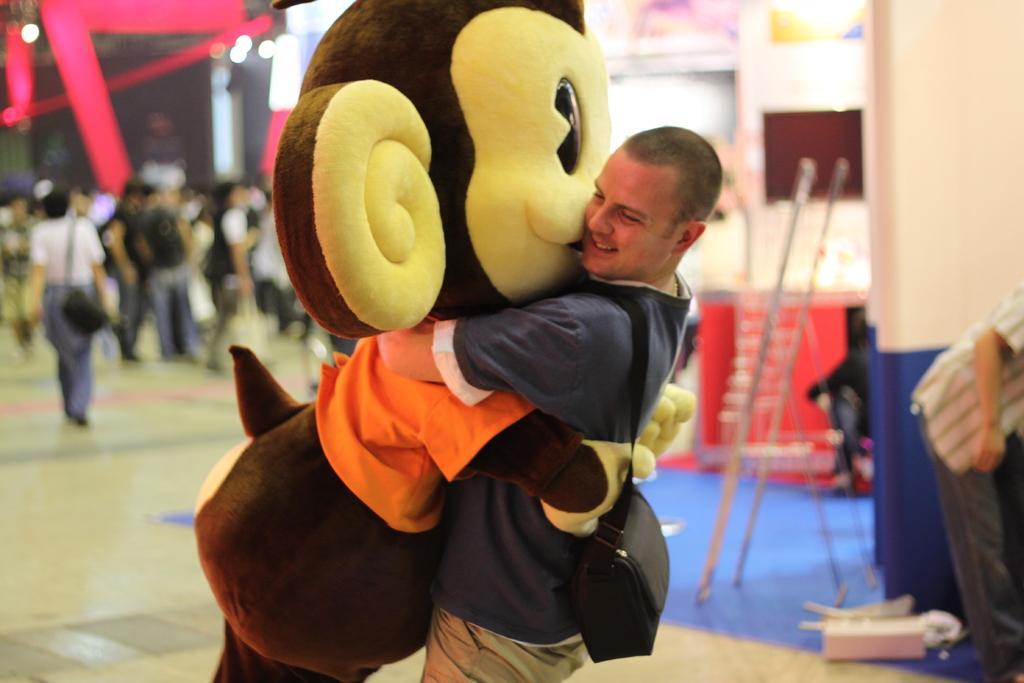Please provide a concise description of this image. Here I can see a man wearing a bag, standing, hugging a toy and smiling. It seems like a person wearing his costume. On the right side there is a person standing facing towards right side. Beside him there is a pillar. At the bottom there are few objects and two mike stands. On the left side there are many people standing and walking on the floor. The background is blurred. 